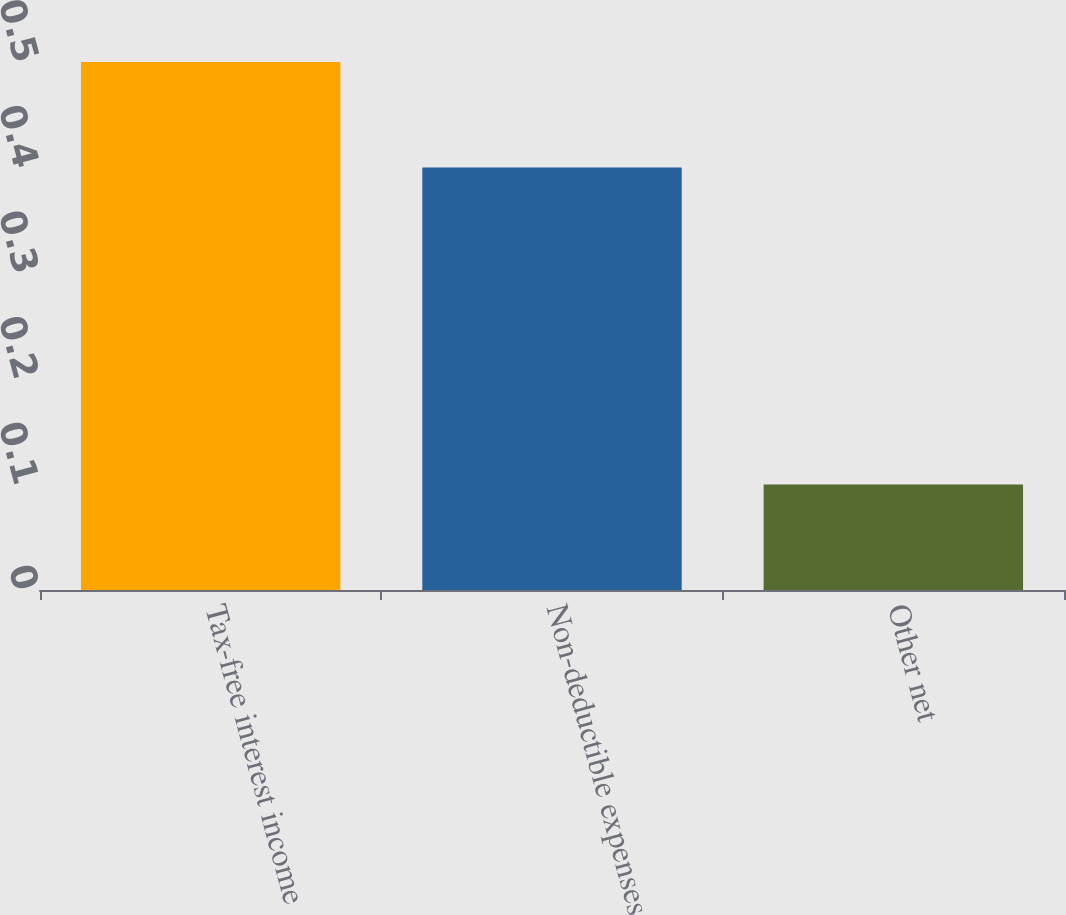Convert chart. <chart><loc_0><loc_0><loc_500><loc_500><bar_chart><fcel>Tax-free interest income<fcel>Non-deductible expenses<fcel>Other net<nl><fcel>0.5<fcel>0.4<fcel>0.1<nl></chart> 